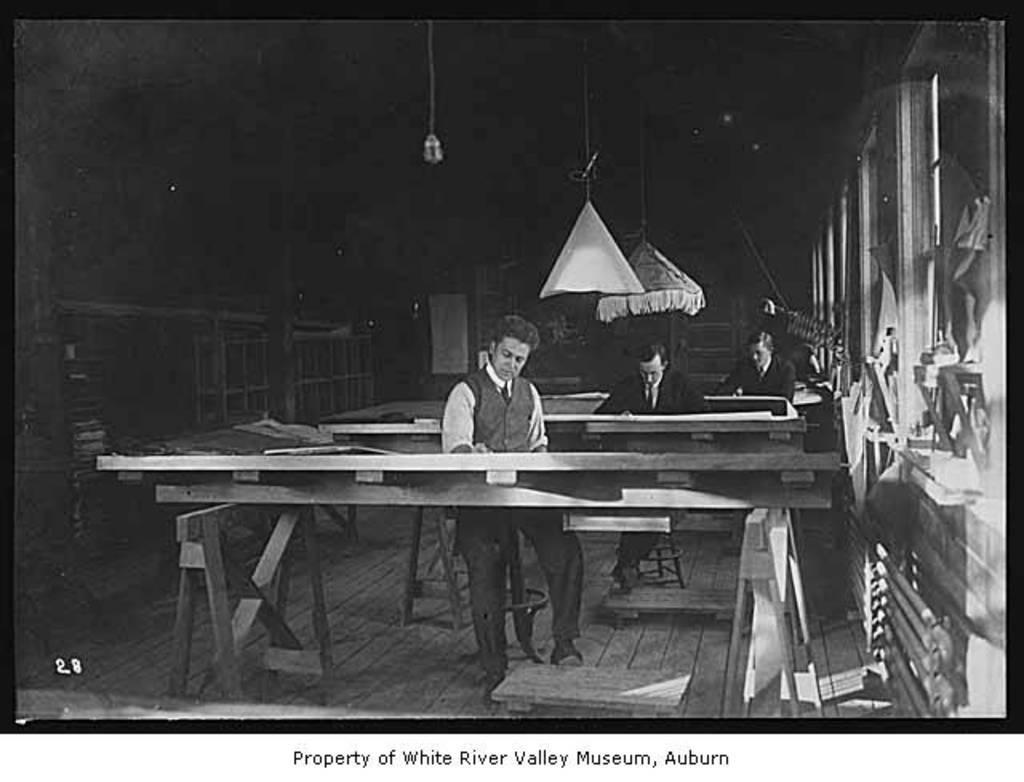Could you give a brief overview of what you see in this image? In the picture there are three man sitting on the chairs and doing work on the table. In the background there is a dark in color and it is a wooden floor. 